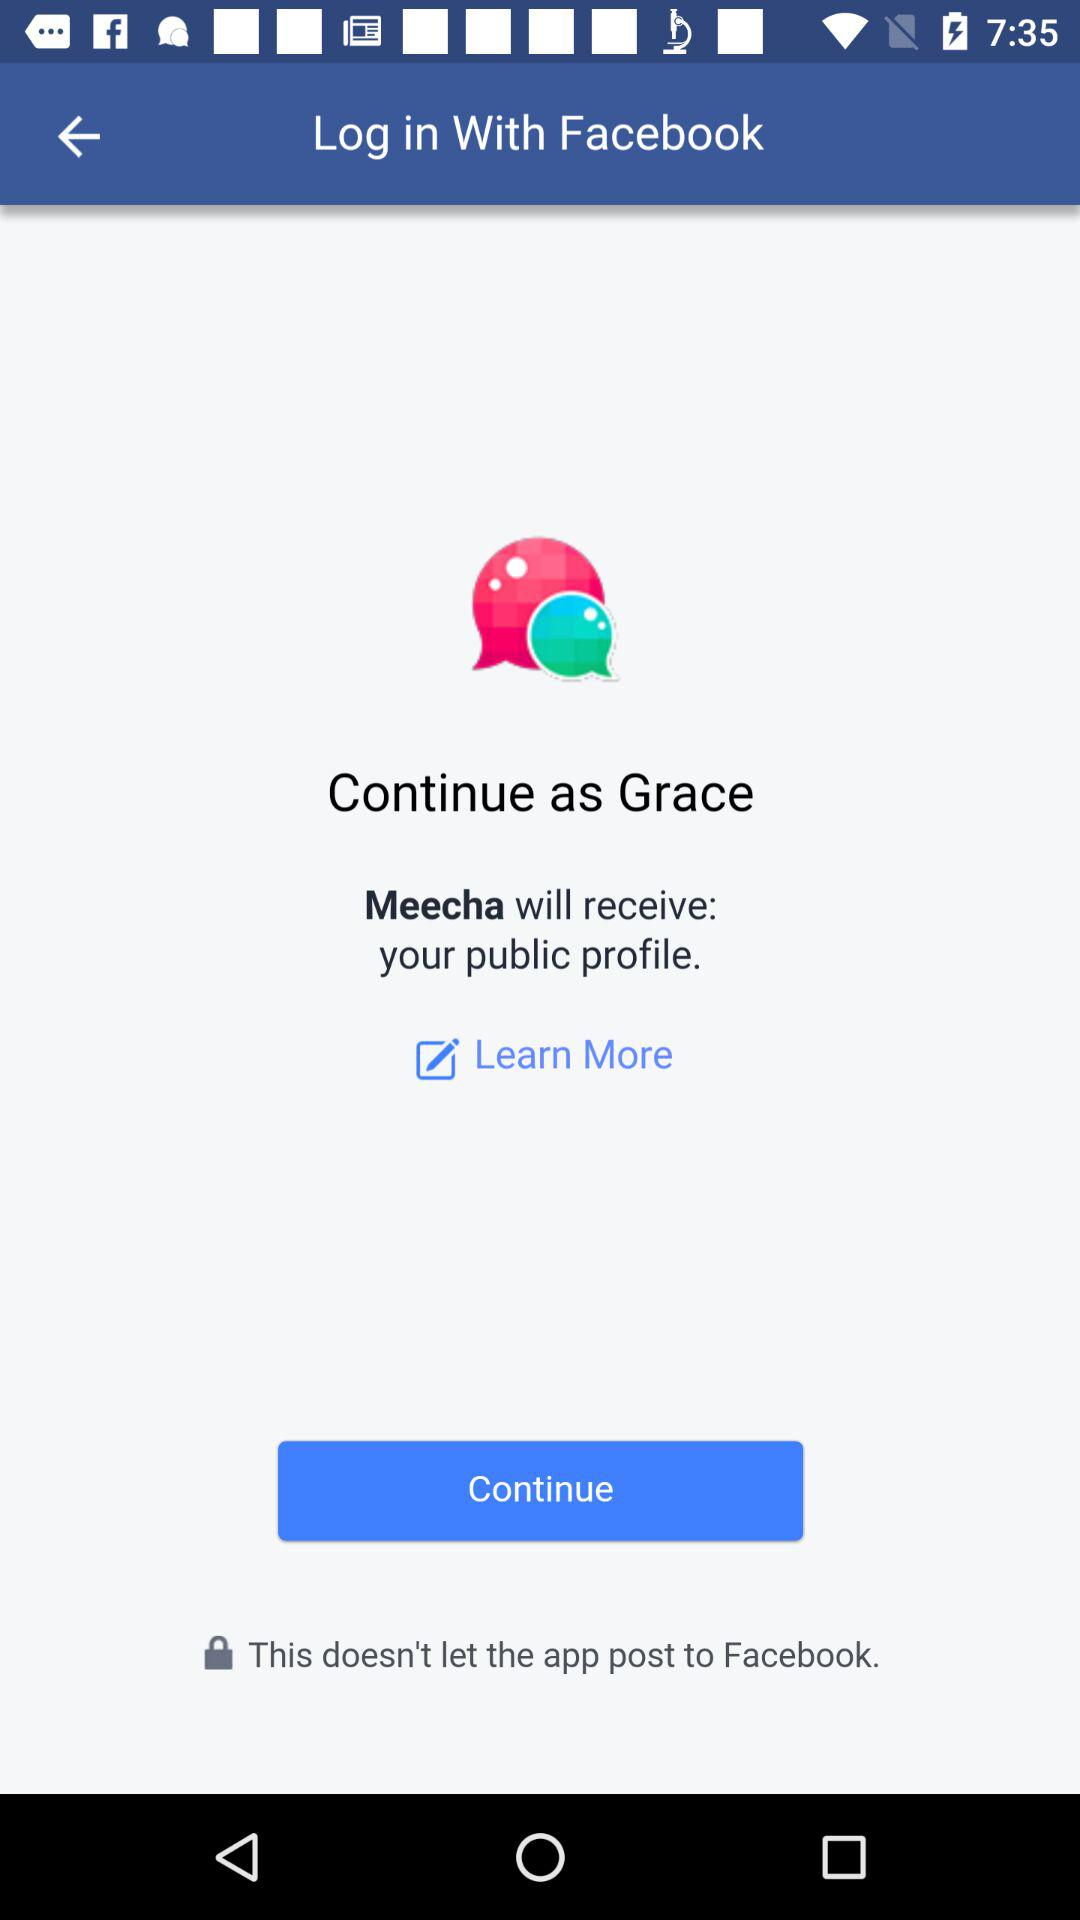What application is asking for permission? The application asking for permission is "Meecha". 